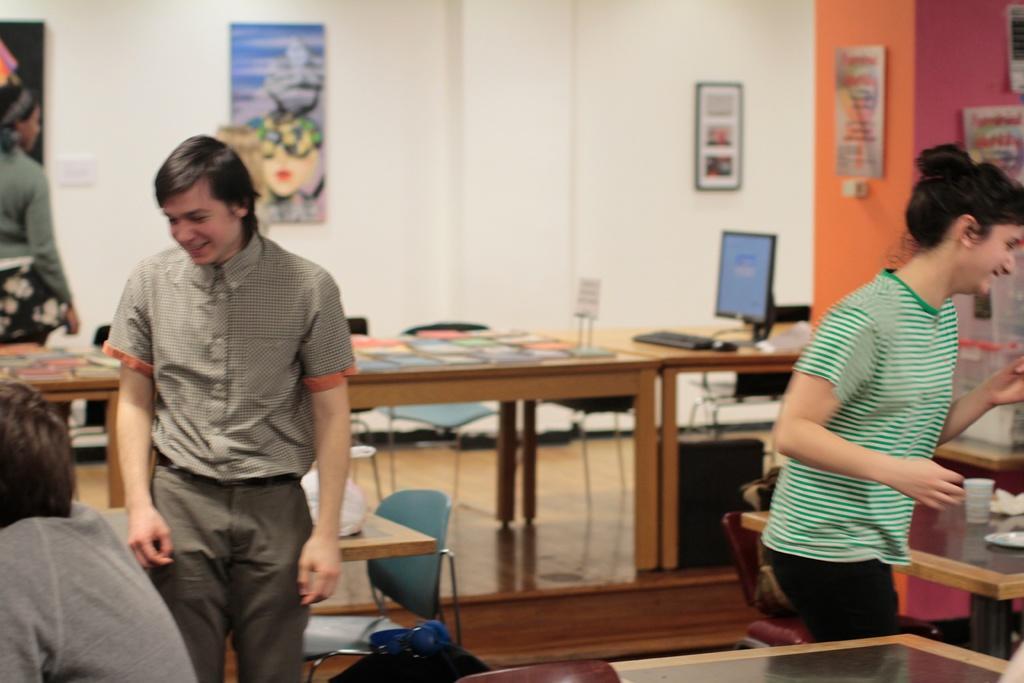Please provide a concise description of this image. In this image we can see two persons are standing and smiling, and in front here is the table and books and some objects on it, and here a person is sitting, and here is the wall. 